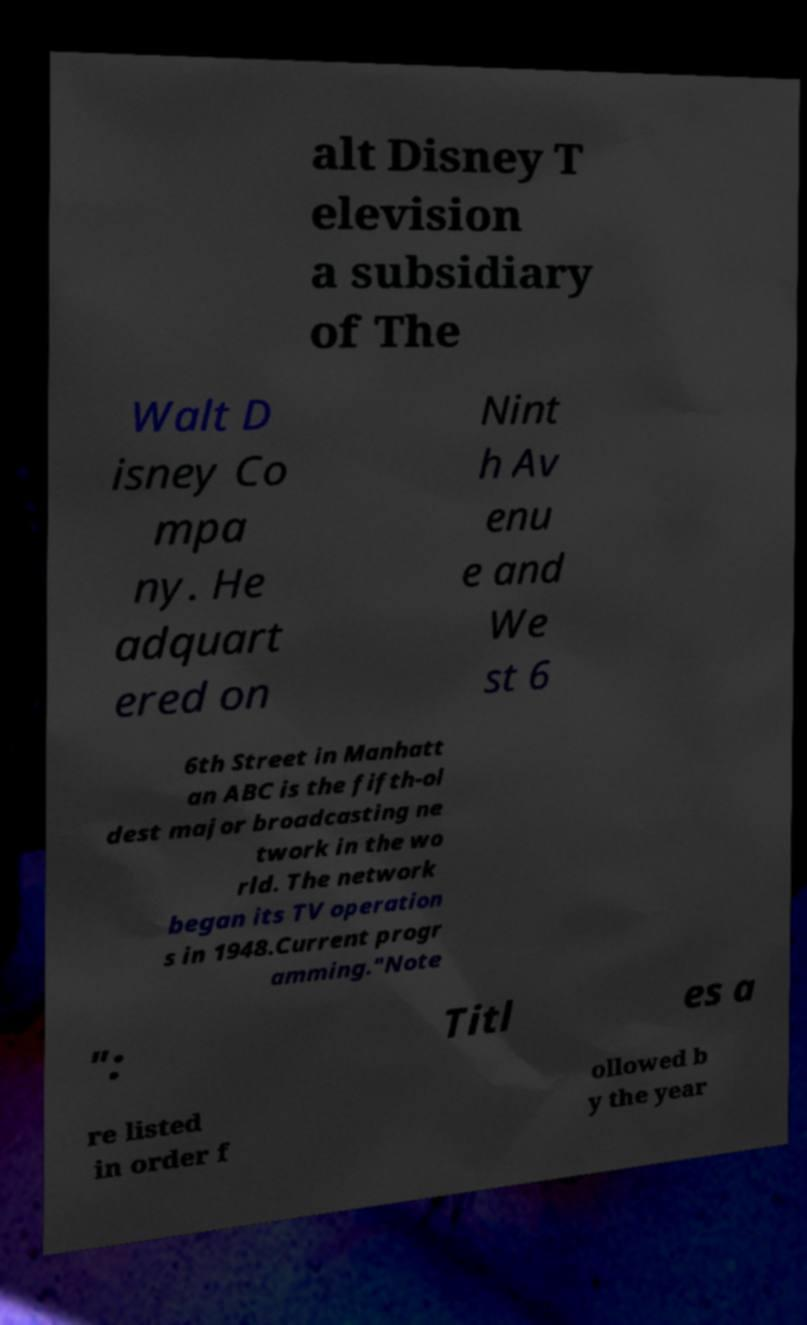Can you accurately transcribe the text from the provided image for me? alt Disney T elevision a subsidiary of The Walt D isney Co mpa ny. He adquart ered on Nint h Av enu e and We st 6 6th Street in Manhatt an ABC is the fifth-ol dest major broadcasting ne twork in the wo rld. The network began its TV operation s in 1948.Current progr amming."Note ": Titl es a re listed in order f ollowed b y the year 